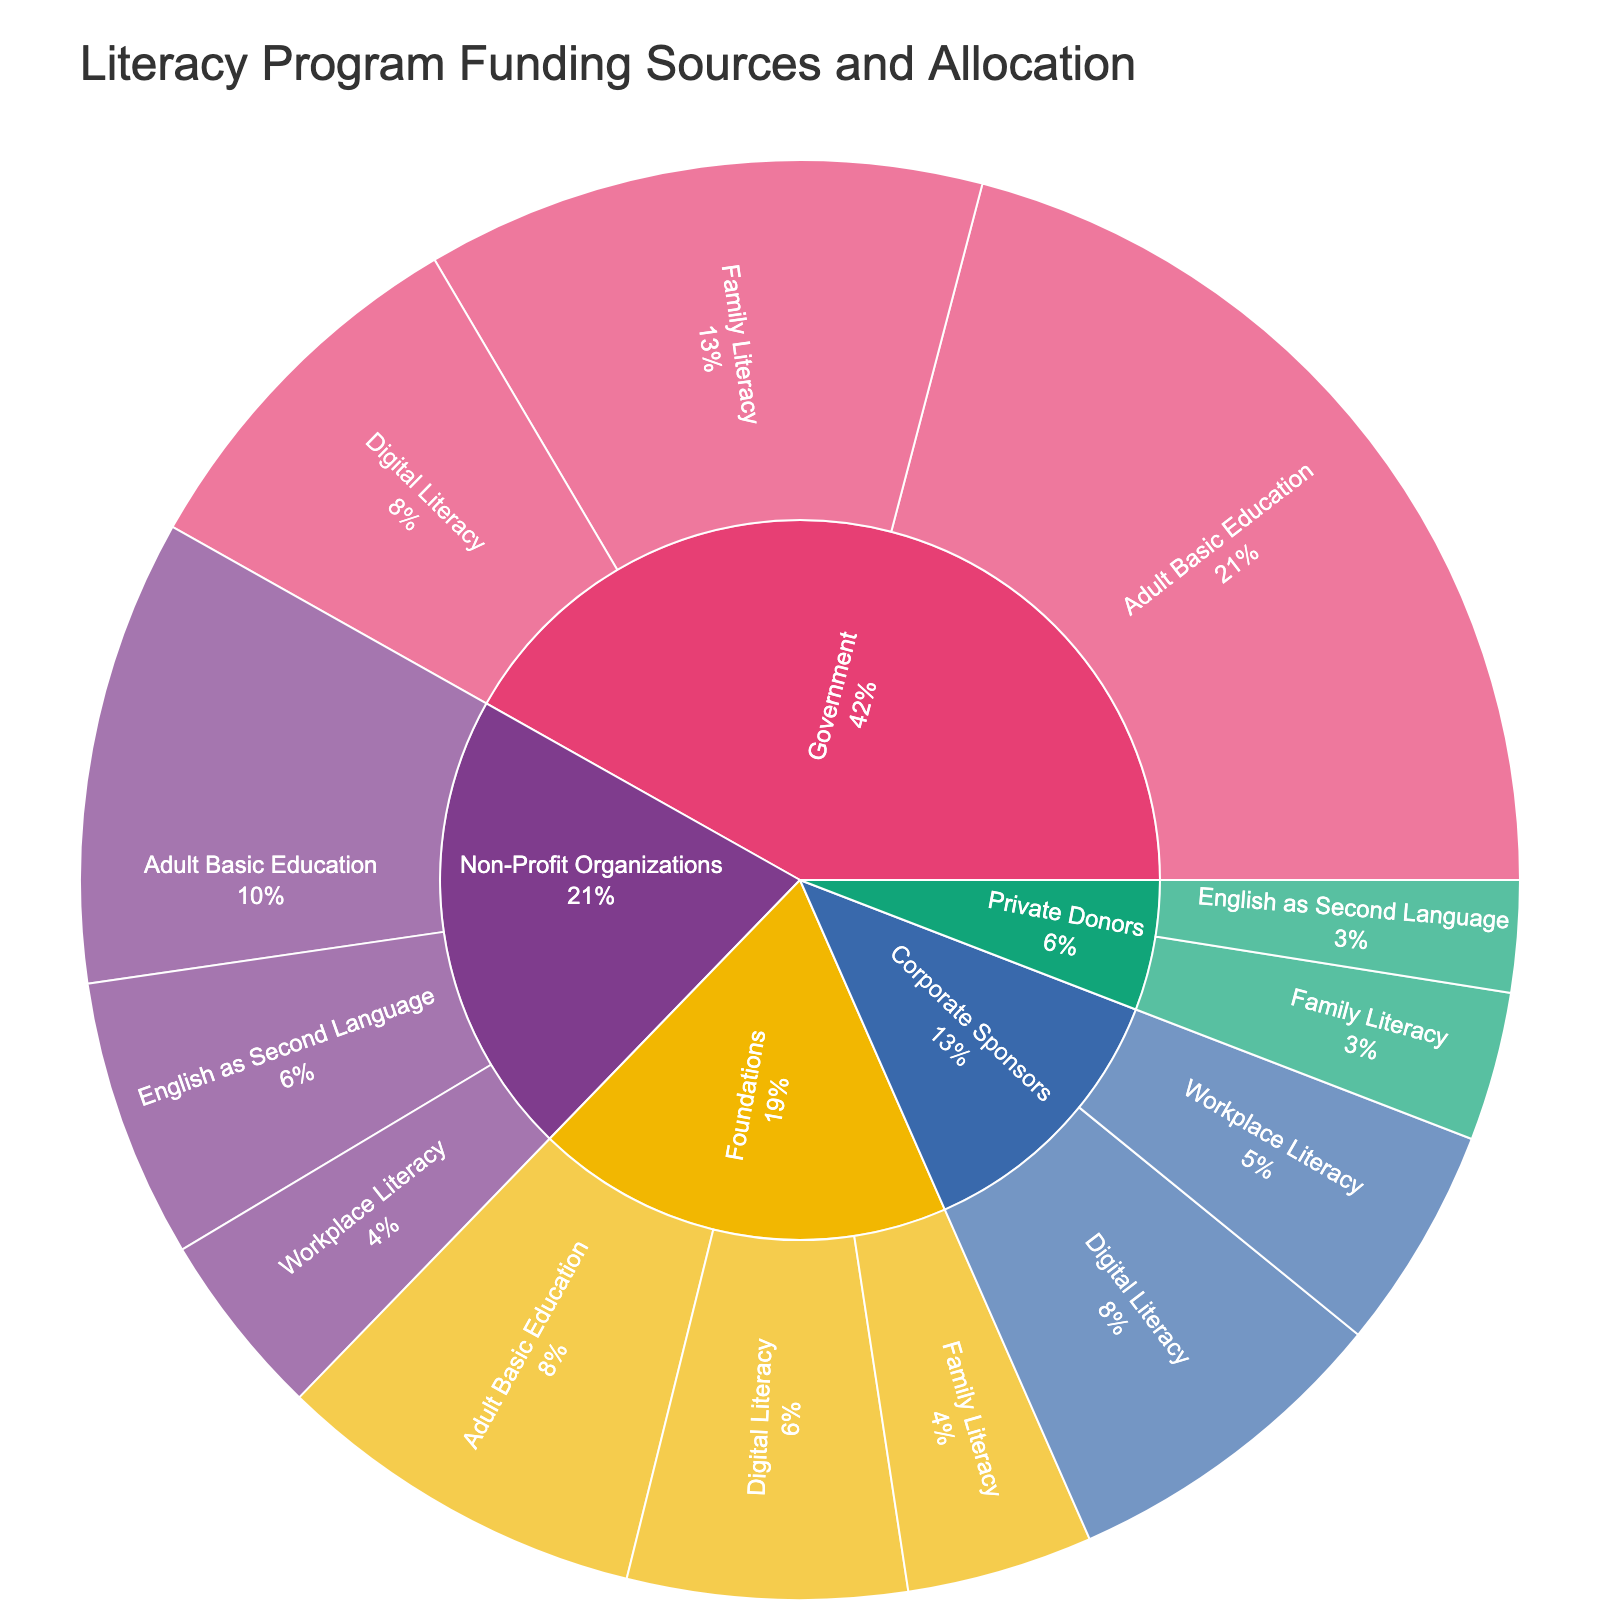What's the title of the plot? The title is typically found at the top of the plot and describes the content. In this case, it is clearly visible.
Answer: Literacy Program Funding Sources and Allocation Which funding source has the highest total allocation? To find this, we look at the outermost segments for each funding source and sum their corresponding allocations. The Government segment appears largest.
Answer: Government How much funding does Corporate Sponsors allocate to Digital Literacy? Locate the Corporate Sponsors segment and find the subsegment for Digital Literacy. The value is listed in the allocation data.
Answer: 1,800,000 What is the combined allocation for 'Family Literacy' programs from all funding sources? Sum the allocations for Family Literacy across different funding sources: Government (3,000,000) + Private Donors (800,000) + Foundations (1,000,000).
Answer: 4,800,000 Which program type receives the least funding overall? Compare the aggregate sizes of all segments for each program type. Workplace Literacy is the smallest.
Answer: Workplace Literacy How does the allocation for 'Adult Basic Education' from Foundations compare to Government's allocation for the same program? Compare the two specific segments visually or by value: Foundations (2,000,000) vs. Government (5,000,000).
Answer: Government's allocation is larger What's the total funding provided by Non-Profit Organizations? Sum the allocations for all program types funded by Non-Profit Organizations: (2,500,000 + 1,500,000 + 1,000,000).
Answer: 5,000,000 What percentage of the total funding does the Digital Literacy program receive from all sources? First, calculate the total allocation for Digital Literacy (2,000,000 + 1,800,000 + 1,500,000). Then, divide by the sum of all allocations and multiply by 100.
Answer: 17.7% Which funding source contributes the most to English as a Second Language programs? Compare the segments for ESL under each funding source: Non-Profit Organizations (1,500,000) and Private Donors (600,000).
Answer: Non-Profit Organizations 